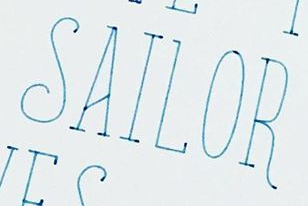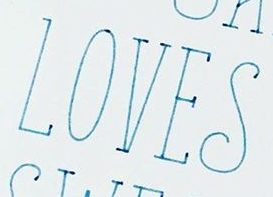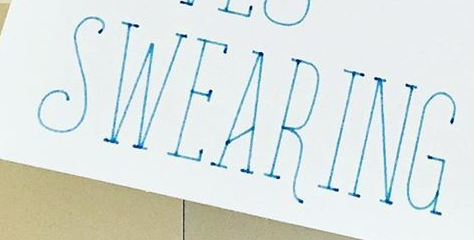What words can you see in these images in sequence, separated by a semicolon? SAILOR; LOVES; SWEARING 